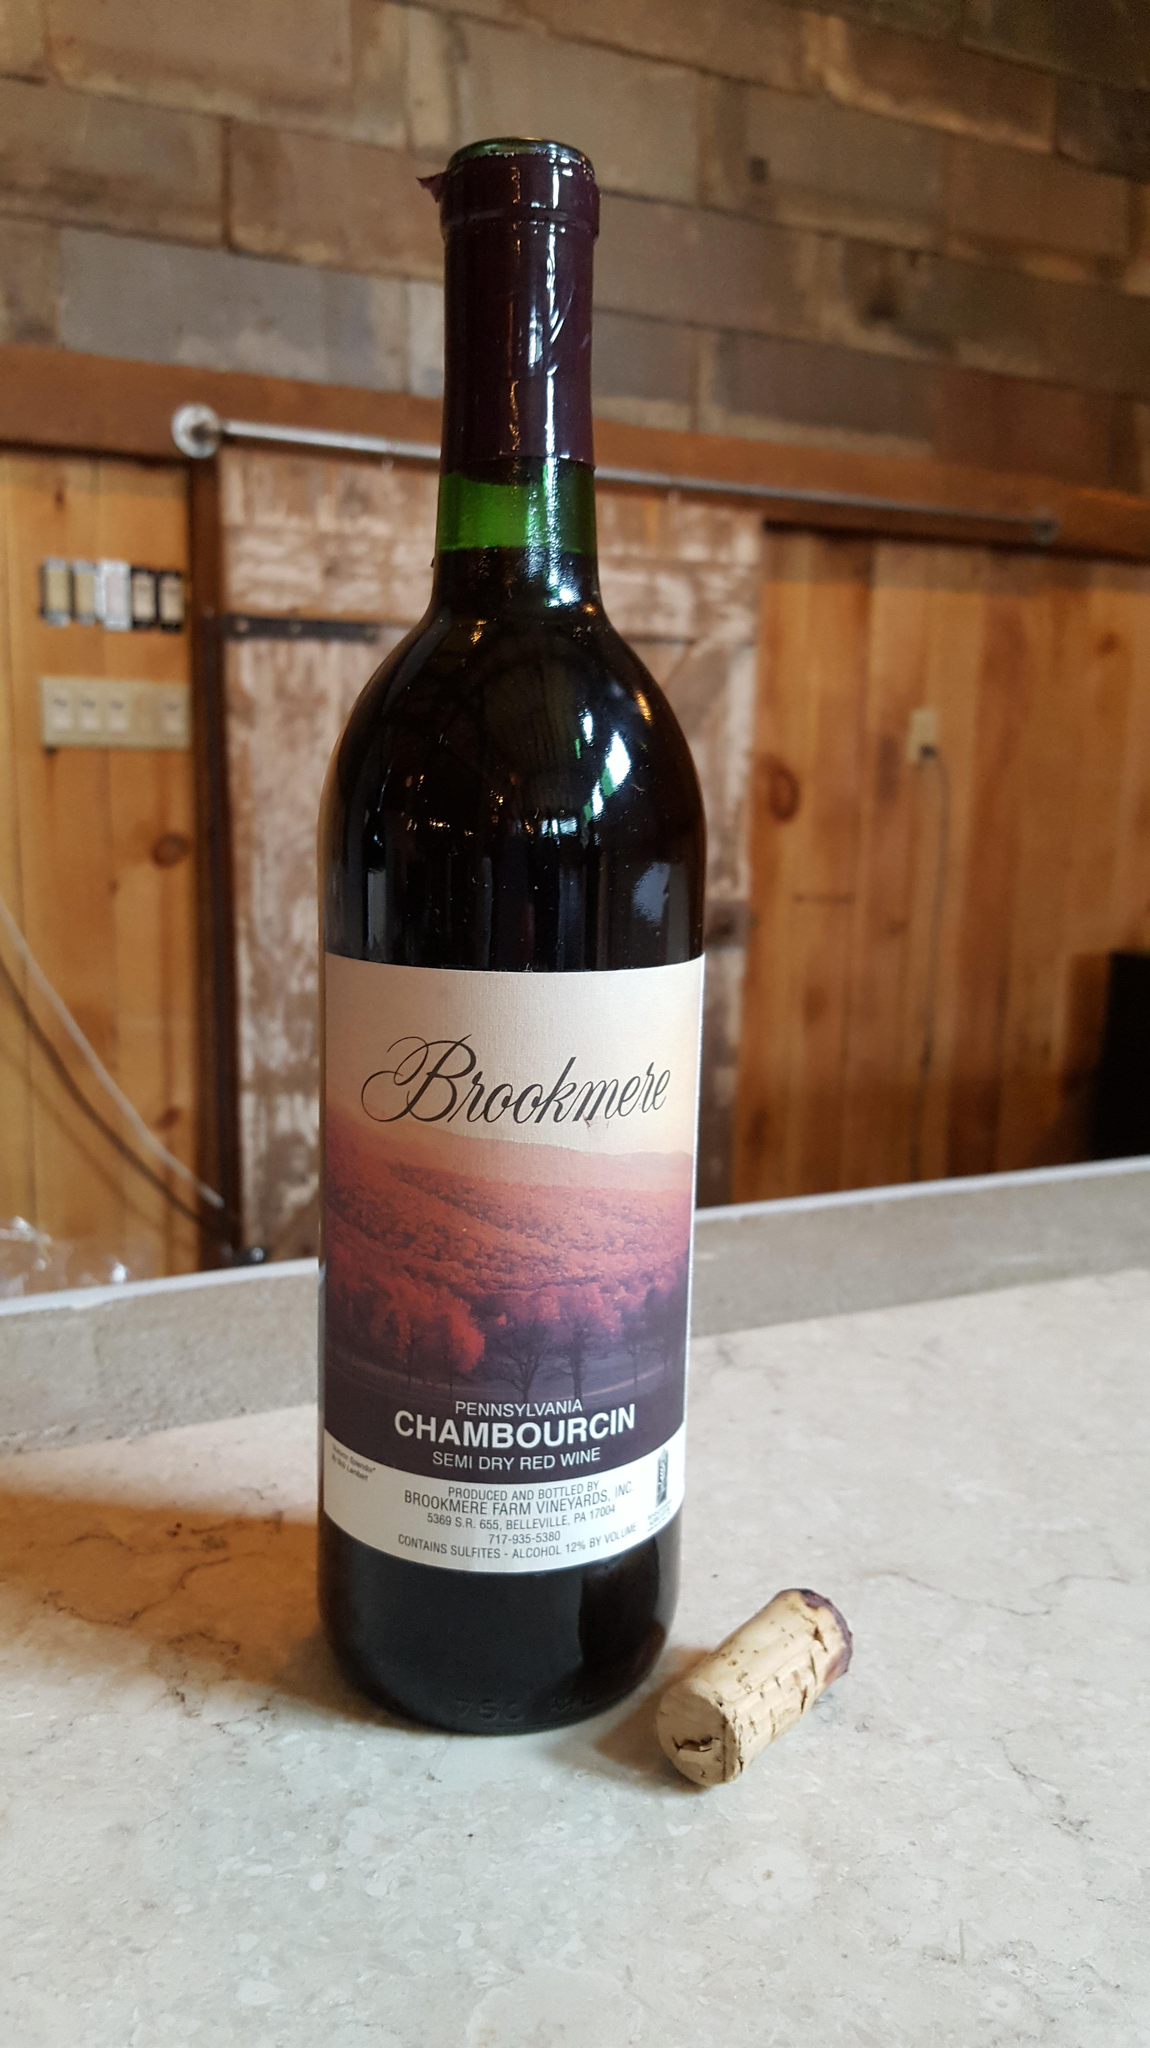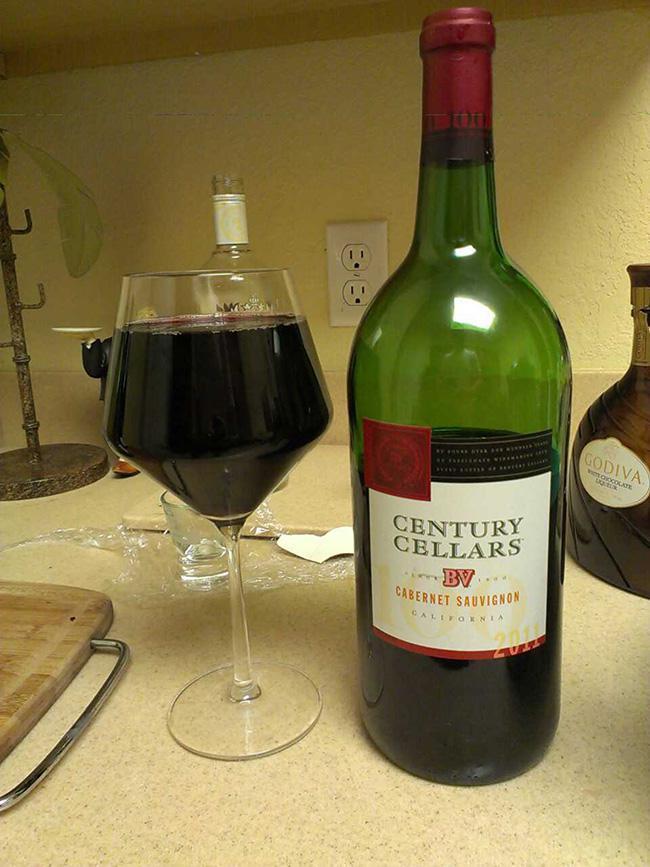The first image is the image on the left, the second image is the image on the right. Considering the images on both sides, is "A green wine bottle is to the right of a glass of wine in the right image." valid? Answer yes or no. Yes. The first image is the image on the left, the second image is the image on the right. Assess this claim about the two images: "All pictures include at least one wine glass.". Correct or not? Answer yes or no. No. 